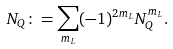<formula> <loc_0><loc_0><loc_500><loc_500>N _ { Q } \colon = \sum _ { m _ { L } } ( - 1 ) ^ { 2 m _ { L } } N _ { Q } ^ { m _ { L } } .</formula> 